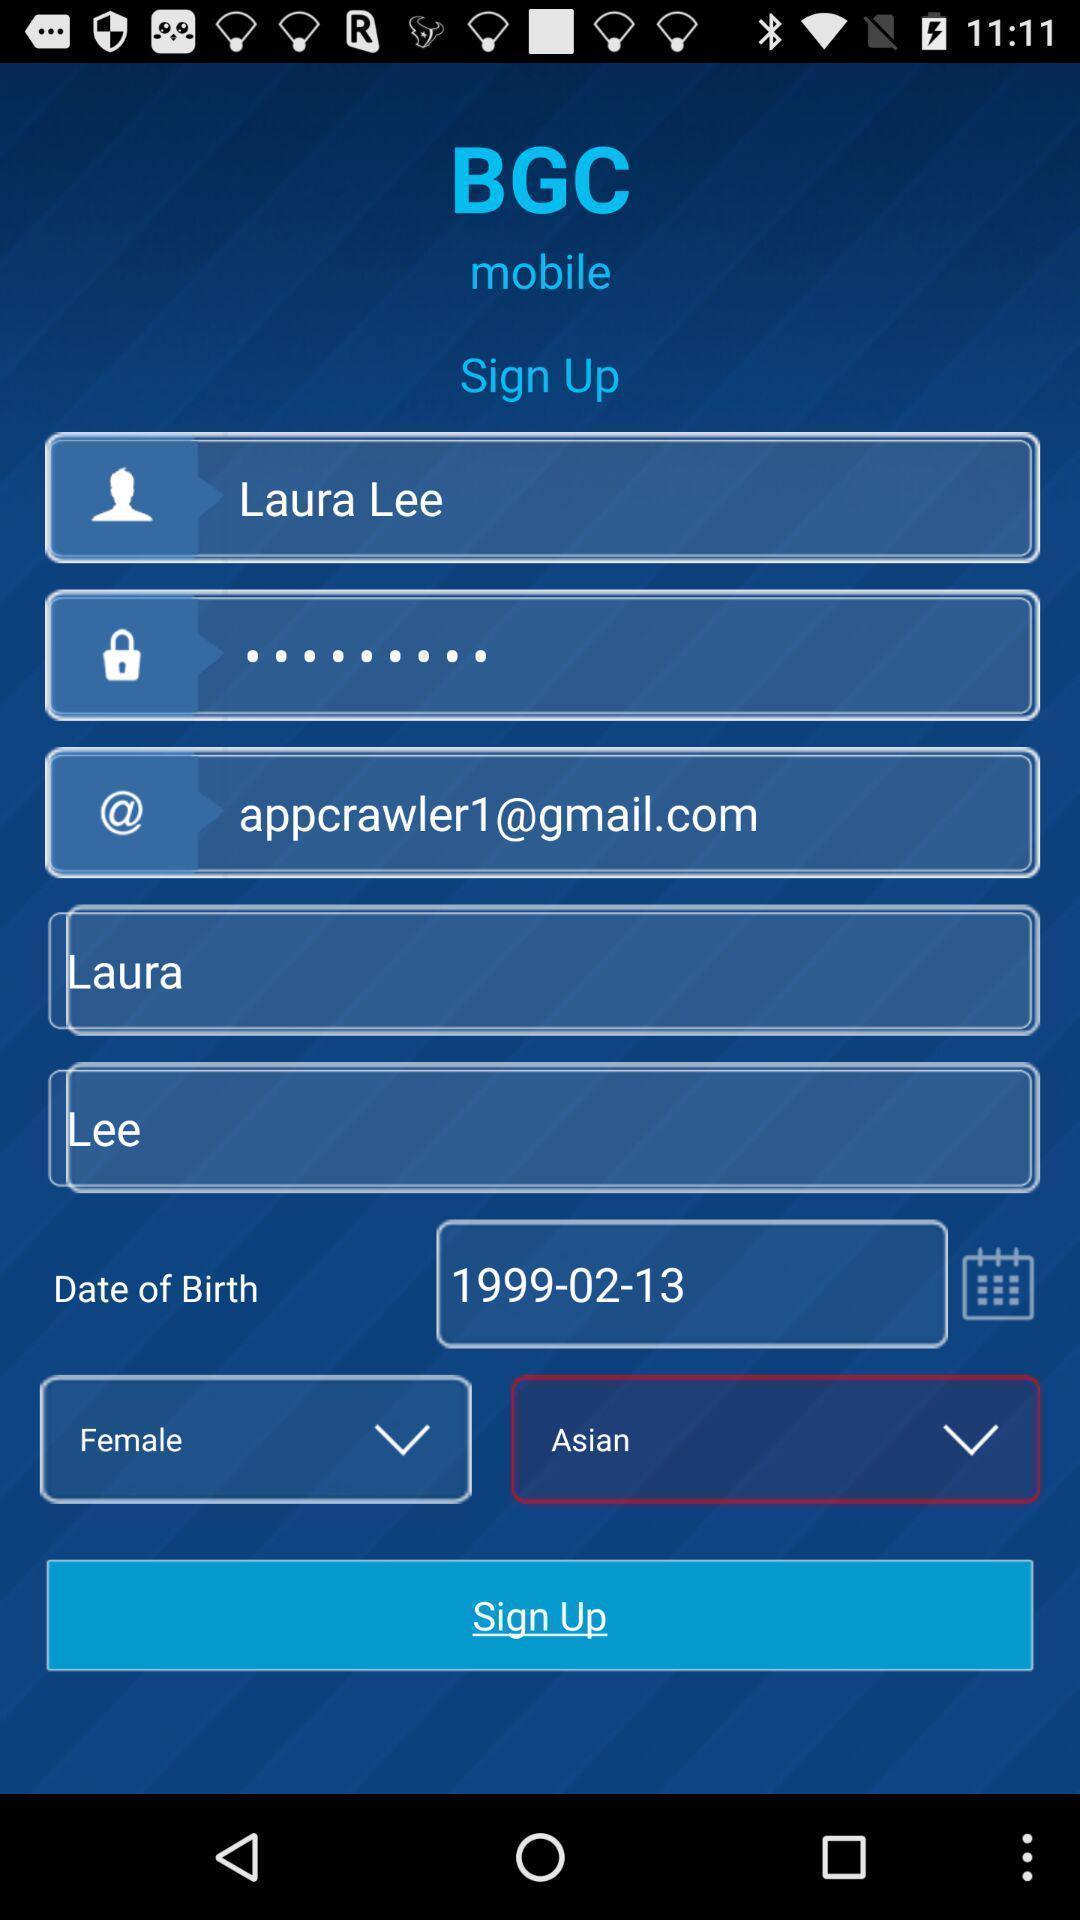What details can you identify in this image? Sign up page. 